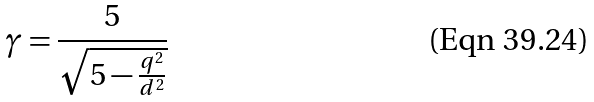Convert formula to latex. <formula><loc_0><loc_0><loc_500><loc_500>\gamma = \frac { 5 } { \sqrt { 5 - \frac { q ^ { 2 } } { d ^ { 2 } } } }</formula> 